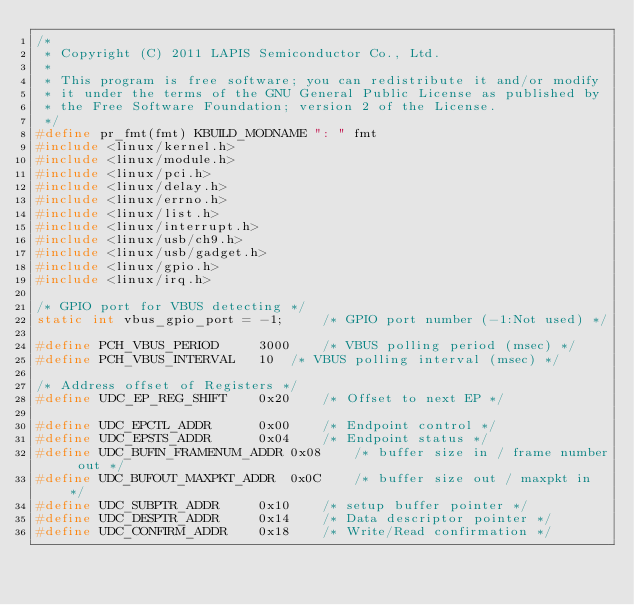<code> <loc_0><loc_0><loc_500><loc_500><_C_>/*
 * Copyright (C) 2011 LAPIS Semiconductor Co., Ltd.
 *
 * This program is free software; you can redistribute it and/or modify
 * it under the terms of the GNU General Public License as published by
 * the Free Software Foundation; version 2 of the License.
 */
#define pr_fmt(fmt) KBUILD_MODNAME ": " fmt
#include <linux/kernel.h>
#include <linux/module.h>
#include <linux/pci.h>
#include <linux/delay.h>
#include <linux/errno.h>
#include <linux/list.h>
#include <linux/interrupt.h>
#include <linux/usb/ch9.h>
#include <linux/usb/gadget.h>
#include <linux/gpio.h>
#include <linux/irq.h>

/* GPIO port for VBUS detecting */
static int vbus_gpio_port = -1;		/* GPIO port number (-1:Not used) */

#define PCH_VBUS_PERIOD		3000	/* VBUS polling period (msec) */
#define PCH_VBUS_INTERVAL	10	/* VBUS polling interval (msec) */

/* Address offset of Registers */
#define UDC_EP_REG_SHIFT	0x20	/* Offset to next EP */

#define UDC_EPCTL_ADDR		0x00	/* Endpoint control */
#define UDC_EPSTS_ADDR		0x04	/* Endpoint status */
#define UDC_BUFIN_FRAMENUM_ADDR	0x08	/* buffer size in / frame number out */
#define UDC_BUFOUT_MAXPKT_ADDR	0x0C	/* buffer size out / maxpkt in */
#define UDC_SUBPTR_ADDR		0x10	/* setup buffer pointer */
#define UDC_DESPTR_ADDR		0x14	/* Data descriptor pointer */
#define UDC_CONFIRM_ADDR	0x18	/* Write/Read confirmation */
</code> 